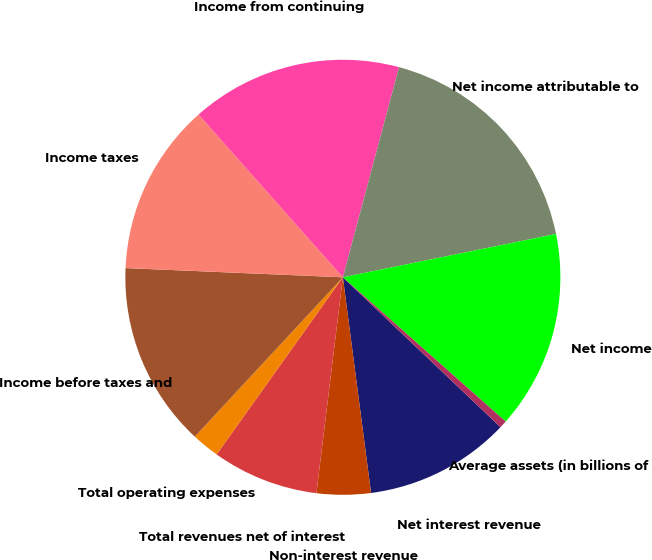Convert chart. <chart><loc_0><loc_0><loc_500><loc_500><pie_chart><fcel>Net interest revenue<fcel>Non-interest revenue<fcel>Total revenues net of interest<fcel>Total operating expenses<fcel>Income before taxes and<fcel>Income taxes<fcel>Income from continuing<fcel>Net income attributable to<fcel>Net income<fcel>Average assets (in billions of<nl><fcel>10.83%<fcel>4.01%<fcel>7.91%<fcel>2.06%<fcel>13.76%<fcel>12.78%<fcel>15.7%<fcel>17.65%<fcel>14.73%<fcel>0.56%<nl></chart> 